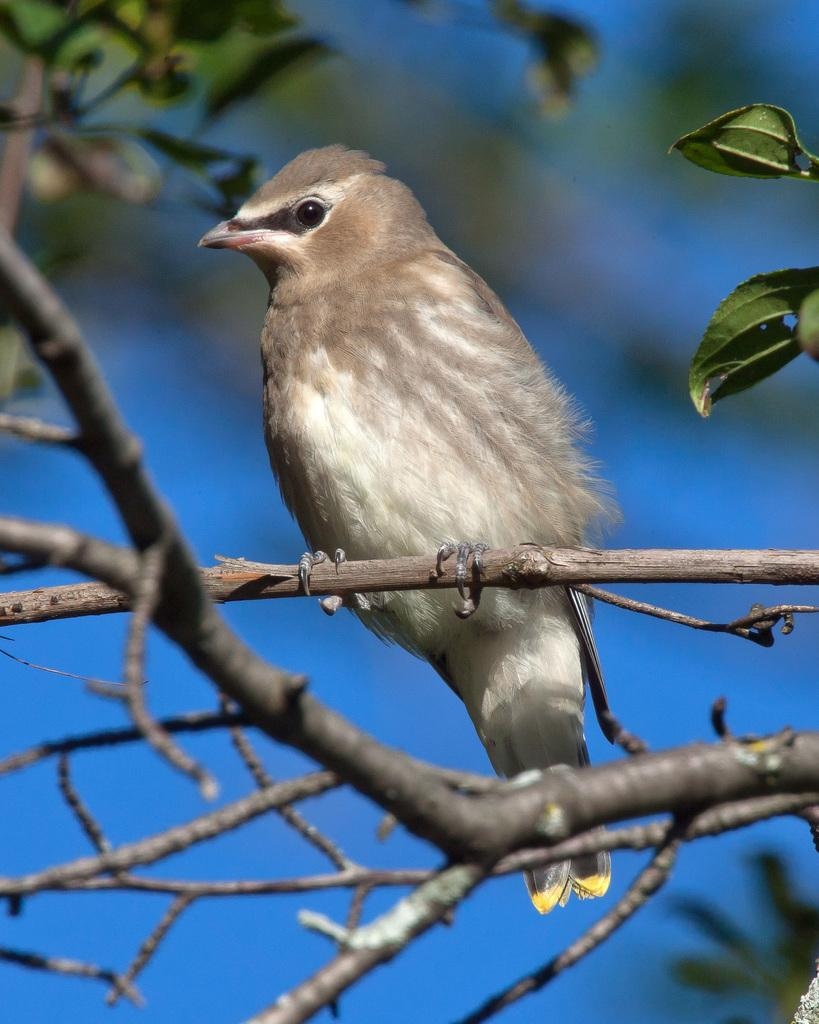What type of animal can be seen in the image? There is a bird in the image. Where is the bird located? The bird is on a tree branch. Can you describe the background of the image? The background of the image is slightly blurred, and the blue color sky is visible. What type of harmony is the bird playing on the tree branch in the image? There is no musical instrument or harmony present in the image; it features a bird on a tree branch. What type of cream is being used to paint the station in the image? There is no station or painting activity present in the image; it features a bird on a tree branch with a blurred background and a visible blue sky. 